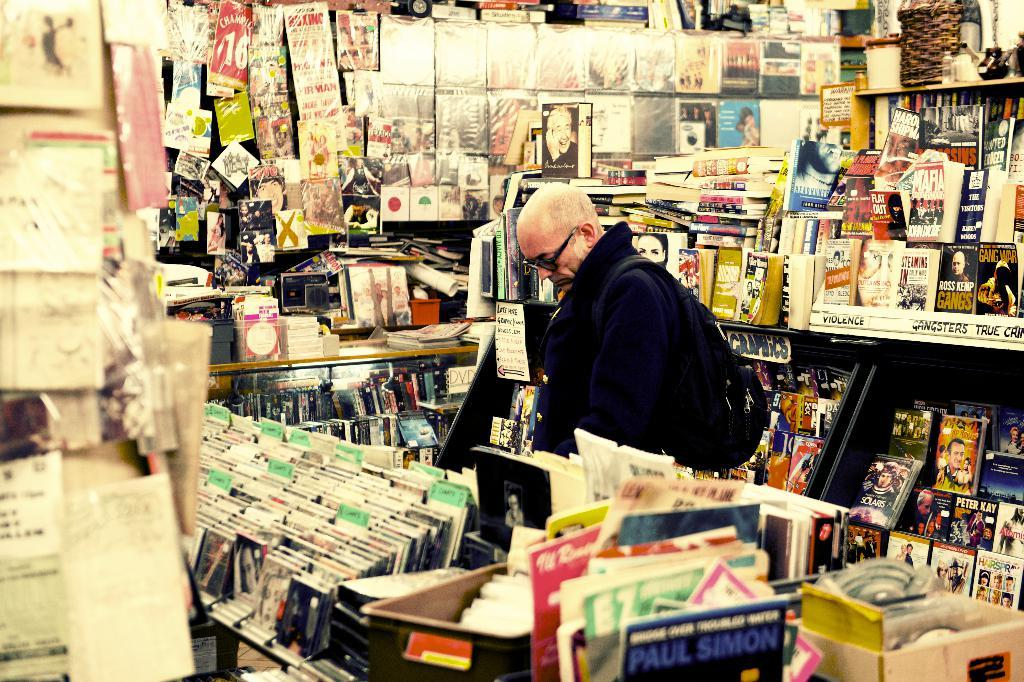<image>
Render a clear and concise summary of the photo. A man is looking through a shelf of records, including one by Paul Simon. 